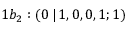Convert formula to latex. <formula><loc_0><loc_0><loc_500><loc_500>1 b _ { 2 } \colon ( 0 \, | \, 1 , 0 , 0 , 1 ; 1 )</formula> 